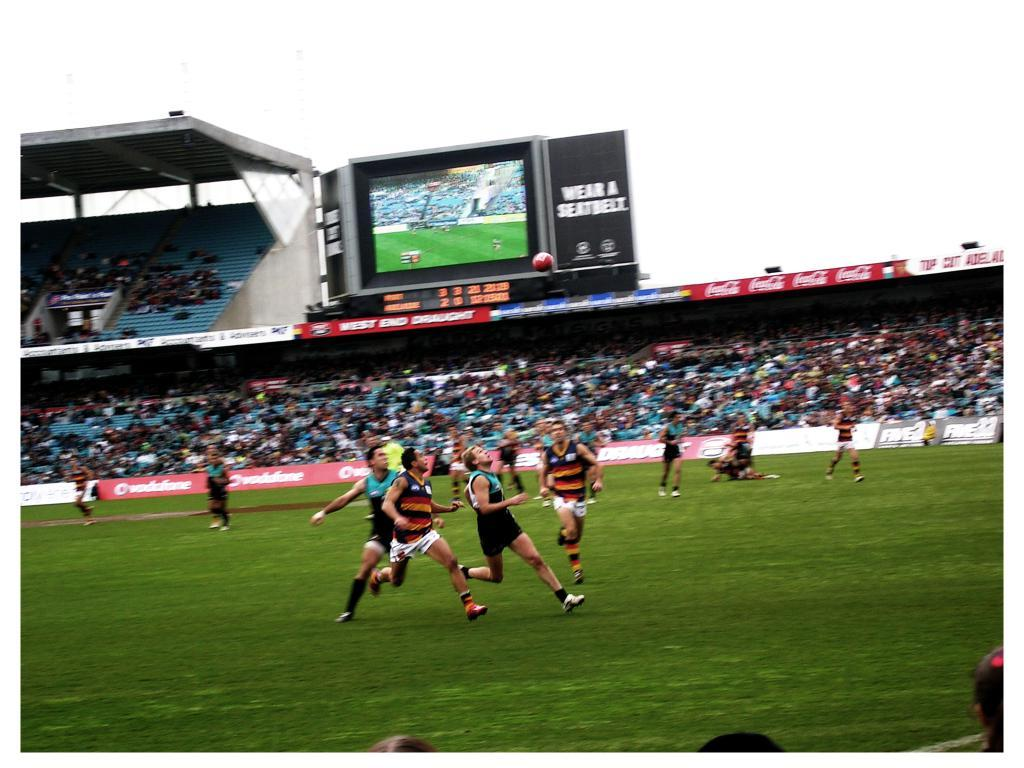What are the people in the image doing? The people are running in the image. What sport are they playing? They are playing football. What can be seen at the top of the image? There is an electronic display and the sky visible at the top of the image. Reasoning: Let' Let's think step by step in order to produce the conversation. We start by identifying the main action of the people in the image, which is running. Then, we clarify that they are playing football, which is a common sport involving running. Finally, we mention the electronic display and the sky, which are visible at the top of the image. Absurd Question/Answer: How many pears are being held by the owl in the image? There is no owl or pear present in the image. 